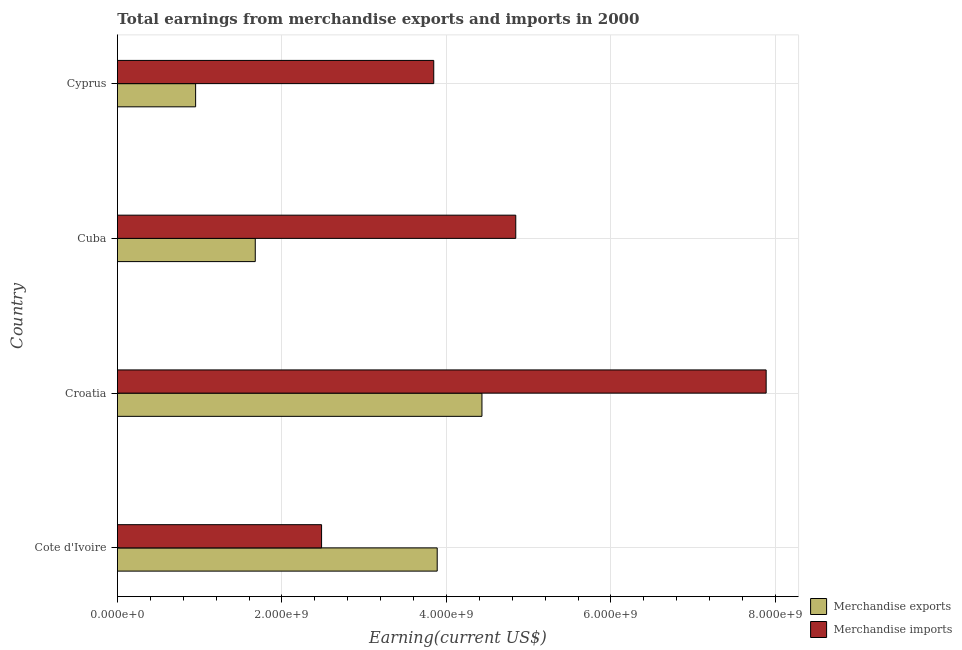How many different coloured bars are there?
Keep it short and to the point. 2. How many groups of bars are there?
Offer a very short reply. 4. Are the number of bars on each tick of the Y-axis equal?
Provide a succinct answer. Yes. What is the label of the 3rd group of bars from the top?
Offer a terse response. Croatia. In how many cases, is the number of bars for a given country not equal to the number of legend labels?
Your answer should be compact. 0. What is the earnings from merchandise imports in Croatia?
Provide a short and direct response. 7.89e+09. Across all countries, what is the maximum earnings from merchandise imports?
Keep it short and to the point. 7.89e+09. Across all countries, what is the minimum earnings from merchandise imports?
Your answer should be very brief. 2.48e+09. In which country was the earnings from merchandise imports maximum?
Offer a terse response. Croatia. In which country was the earnings from merchandise imports minimum?
Give a very brief answer. Cote d'Ivoire. What is the total earnings from merchandise imports in the graph?
Provide a short and direct response. 1.91e+1. What is the difference between the earnings from merchandise imports in Cote d'Ivoire and that in Cyprus?
Make the answer very short. -1.36e+09. What is the difference between the earnings from merchandise imports in Croatia and the earnings from merchandise exports in Cote d'Ivoire?
Offer a very short reply. 4.00e+09. What is the average earnings from merchandise imports per country?
Provide a short and direct response. 4.76e+09. What is the difference between the earnings from merchandise exports and earnings from merchandise imports in Cuba?
Your response must be concise. -3.17e+09. In how many countries, is the earnings from merchandise imports greater than 3200000000 US$?
Give a very brief answer. 3. What is the ratio of the earnings from merchandise imports in Cote d'Ivoire to that in Cyprus?
Give a very brief answer. 0.65. What is the difference between the highest and the second highest earnings from merchandise imports?
Offer a very short reply. 3.04e+09. What is the difference between the highest and the lowest earnings from merchandise exports?
Keep it short and to the point. 3.48e+09. In how many countries, is the earnings from merchandise imports greater than the average earnings from merchandise imports taken over all countries?
Provide a succinct answer. 2. Is the sum of the earnings from merchandise imports in Croatia and Cyprus greater than the maximum earnings from merchandise exports across all countries?
Provide a succinct answer. Yes. What does the 2nd bar from the top in Cuba represents?
Give a very brief answer. Merchandise exports. What does the 2nd bar from the bottom in Cote d'Ivoire represents?
Make the answer very short. Merchandise imports. How many bars are there?
Your answer should be compact. 8. Are all the bars in the graph horizontal?
Keep it short and to the point. Yes. What is the difference between two consecutive major ticks on the X-axis?
Provide a succinct answer. 2.00e+09. Are the values on the major ticks of X-axis written in scientific E-notation?
Your answer should be very brief. Yes. Does the graph contain any zero values?
Give a very brief answer. No. Does the graph contain grids?
Ensure brevity in your answer.  Yes. Where does the legend appear in the graph?
Provide a short and direct response. Bottom right. How many legend labels are there?
Ensure brevity in your answer.  2. What is the title of the graph?
Your answer should be compact. Total earnings from merchandise exports and imports in 2000. Does "Commercial service exports" appear as one of the legend labels in the graph?
Your response must be concise. No. What is the label or title of the X-axis?
Provide a short and direct response. Earning(current US$). What is the label or title of the Y-axis?
Provide a short and direct response. Country. What is the Earning(current US$) of Merchandise exports in Cote d'Ivoire?
Keep it short and to the point. 3.89e+09. What is the Earning(current US$) in Merchandise imports in Cote d'Ivoire?
Provide a short and direct response. 2.48e+09. What is the Earning(current US$) of Merchandise exports in Croatia?
Offer a terse response. 4.43e+09. What is the Earning(current US$) of Merchandise imports in Croatia?
Make the answer very short. 7.89e+09. What is the Earning(current US$) of Merchandise exports in Cuba?
Keep it short and to the point. 1.68e+09. What is the Earning(current US$) in Merchandise imports in Cuba?
Provide a succinct answer. 4.84e+09. What is the Earning(current US$) of Merchandise exports in Cyprus?
Your answer should be compact. 9.51e+08. What is the Earning(current US$) of Merchandise imports in Cyprus?
Provide a short and direct response. 3.85e+09. Across all countries, what is the maximum Earning(current US$) of Merchandise exports?
Ensure brevity in your answer.  4.43e+09. Across all countries, what is the maximum Earning(current US$) in Merchandise imports?
Ensure brevity in your answer.  7.89e+09. Across all countries, what is the minimum Earning(current US$) of Merchandise exports?
Give a very brief answer. 9.51e+08. Across all countries, what is the minimum Earning(current US$) of Merchandise imports?
Your answer should be very brief. 2.48e+09. What is the total Earning(current US$) in Merchandise exports in the graph?
Your answer should be very brief. 1.09e+1. What is the total Earning(current US$) in Merchandise imports in the graph?
Your answer should be compact. 1.91e+1. What is the difference between the Earning(current US$) of Merchandise exports in Cote d'Ivoire and that in Croatia?
Offer a very short reply. -5.44e+08. What is the difference between the Earning(current US$) of Merchandise imports in Cote d'Ivoire and that in Croatia?
Ensure brevity in your answer.  -5.40e+09. What is the difference between the Earning(current US$) of Merchandise exports in Cote d'Ivoire and that in Cuba?
Your answer should be very brief. 2.21e+09. What is the difference between the Earning(current US$) of Merchandise imports in Cote d'Ivoire and that in Cuba?
Provide a succinct answer. -2.36e+09. What is the difference between the Earning(current US$) of Merchandise exports in Cote d'Ivoire and that in Cyprus?
Keep it short and to the point. 2.94e+09. What is the difference between the Earning(current US$) in Merchandise imports in Cote d'Ivoire and that in Cyprus?
Provide a succinct answer. -1.36e+09. What is the difference between the Earning(current US$) in Merchandise exports in Croatia and that in Cuba?
Give a very brief answer. 2.76e+09. What is the difference between the Earning(current US$) of Merchandise imports in Croatia and that in Cuba?
Give a very brief answer. 3.04e+09. What is the difference between the Earning(current US$) of Merchandise exports in Croatia and that in Cyprus?
Make the answer very short. 3.48e+09. What is the difference between the Earning(current US$) in Merchandise imports in Croatia and that in Cyprus?
Give a very brief answer. 4.04e+09. What is the difference between the Earning(current US$) of Merchandise exports in Cuba and that in Cyprus?
Your response must be concise. 7.25e+08. What is the difference between the Earning(current US$) in Merchandise imports in Cuba and that in Cyprus?
Provide a succinct answer. 9.97e+08. What is the difference between the Earning(current US$) in Merchandise exports in Cote d'Ivoire and the Earning(current US$) in Merchandise imports in Croatia?
Ensure brevity in your answer.  -4.00e+09. What is the difference between the Earning(current US$) of Merchandise exports in Cote d'Ivoire and the Earning(current US$) of Merchandise imports in Cuba?
Your answer should be compact. -9.55e+08. What is the difference between the Earning(current US$) in Merchandise exports in Cote d'Ivoire and the Earning(current US$) in Merchandise imports in Cyprus?
Offer a very short reply. 4.20e+07. What is the difference between the Earning(current US$) of Merchandise exports in Croatia and the Earning(current US$) of Merchandise imports in Cuba?
Provide a succinct answer. -4.11e+08. What is the difference between the Earning(current US$) of Merchandise exports in Croatia and the Earning(current US$) of Merchandise imports in Cyprus?
Your answer should be very brief. 5.86e+08. What is the difference between the Earning(current US$) of Merchandise exports in Cuba and the Earning(current US$) of Merchandise imports in Cyprus?
Provide a succinct answer. -2.17e+09. What is the average Earning(current US$) of Merchandise exports per country?
Keep it short and to the point. 2.74e+09. What is the average Earning(current US$) in Merchandise imports per country?
Provide a short and direct response. 4.76e+09. What is the difference between the Earning(current US$) in Merchandise exports and Earning(current US$) in Merchandise imports in Cote d'Ivoire?
Offer a terse response. 1.41e+09. What is the difference between the Earning(current US$) in Merchandise exports and Earning(current US$) in Merchandise imports in Croatia?
Provide a short and direct response. -3.46e+09. What is the difference between the Earning(current US$) in Merchandise exports and Earning(current US$) in Merchandise imports in Cuba?
Your answer should be compact. -3.17e+09. What is the difference between the Earning(current US$) of Merchandise exports and Earning(current US$) of Merchandise imports in Cyprus?
Offer a terse response. -2.90e+09. What is the ratio of the Earning(current US$) of Merchandise exports in Cote d'Ivoire to that in Croatia?
Offer a very short reply. 0.88. What is the ratio of the Earning(current US$) in Merchandise imports in Cote d'Ivoire to that in Croatia?
Your answer should be compact. 0.31. What is the ratio of the Earning(current US$) in Merchandise exports in Cote d'Ivoire to that in Cuba?
Provide a short and direct response. 2.32. What is the ratio of the Earning(current US$) of Merchandise imports in Cote d'Ivoire to that in Cuba?
Provide a succinct answer. 0.51. What is the ratio of the Earning(current US$) in Merchandise exports in Cote d'Ivoire to that in Cyprus?
Make the answer very short. 4.09. What is the ratio of the Earning(current US$) of Merchandise imports in Cote d'Ivoire to that in Cyprus?
Ensure brevity in your answer.  0.65. What is the ratio of the Earning(current US$) of Merchandise exports in Croatia to that in Cuba?
Ensure brevity in your answer.  2.64. What is the ratio of the Earning(current US$) of Merchandise imports in Croatia to that in Cuba?
Your answer should be very brief. 1.63. What is the ratio of the Earning(current US$) of Merchandise exports in Croatia to that in Cyprus?
Provide a succinct answer. 4.66. What is the ratio of the Earning(current US$) in Merchandise imports in Croatia to that in Cyprus?
Provide a short and direct response. 2.05. What is the ratio of the Earning(current US$) of Merchandise exports in Cuba to that in Cyprus?
Your answer should be compact. 1.76. What is the ratio of the Earning(current US$) in Merchandise imports in Cuba to that in Cyprus?
Make the answer very short. 1.26. What is the difference between the highest and the second highest Earning(current US$) of Merchandise exports?
Your answer should be compact. 5.44e+08. What is the difference between the highest and the second highest Earning(current US$) in Merchandise imports?
Provide a succinct answer. 3.04e+09. What is the difference between the highest and the lowest Earning(current US$) in Merchandise exports?
Your answer should be compact. 3.48e+09. What is the difference between the highest and the lowest Earning(current US$) in Merchandise imports?
Make the answer very short. 5.40e+09. 